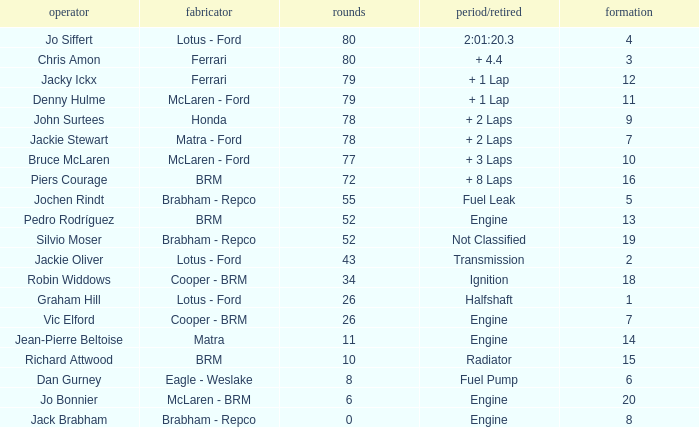When the driver richard attwood has a constructor of brm, what is the number of laps? 10.0. 